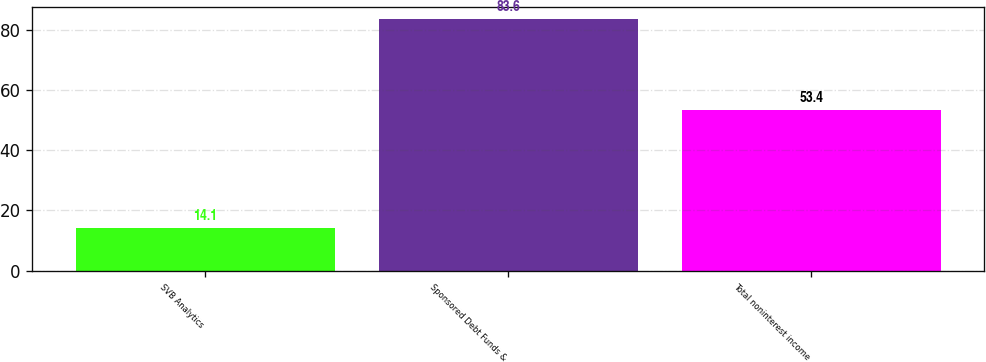<chart> <loc_0><loc_0><loc_500><loc_500><bar_chart><fcel>SVB Analytics<fcel>Sponsored Debt Funds &<fcel>Total noninterest income<nl><fcel>14.1<fcel>83.6<fcel>53.4<nl></chart> 